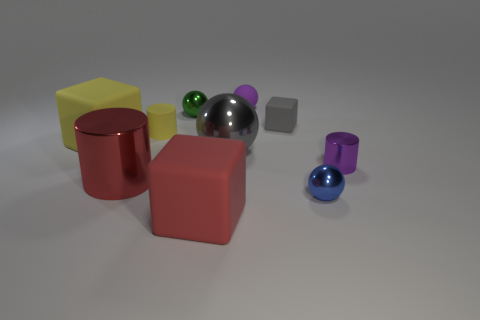Do the big gray thing and the small gray object have the same shape?
Give a very brief answer. No. The cube that is both behind the small blue shiny object and to the left of the big gray sphere is what color?
Provide a short and direct response. Yellow. What size is the matte cube that is the same color as the large cylinder?
Provide a short and direct response. Large. How many tiny things are gray shiny objects or green objects?
Your answer should be compact. 1. Are there any other things of the same color as the tiny rubber sphere?
Your answer should be very brief. Yes. What is the material of the small cylinder to the left of the big cube right of the yellow thing that is on the right side of the large cylinder?
Make the answer very short. Rubber. How many metallic objects are either blue balls or green balls?
Keep it short and to the point. 2. How many purple objects are tiny shiny things or tiny metallic spheres?
Your response must be concise. 1. There is a small shiny ball behind the tiny gray object; is its color the same as the big shiny ball?
Make the answer very short. No. Is the material of the yellow cube the same as the small yellow thing?
Ensure brevity in your answer.  Yes. 